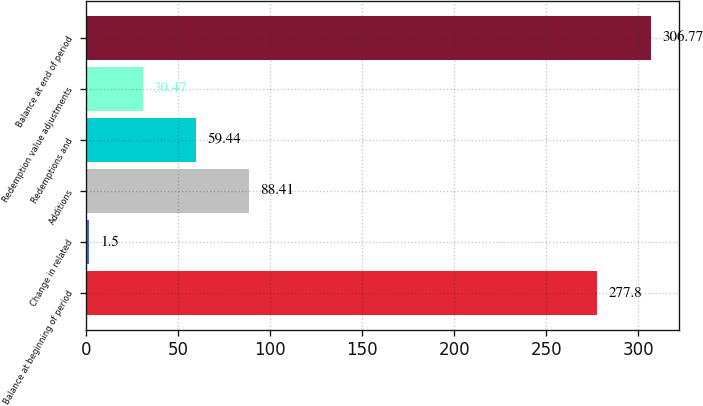Convert chart to OTSL. <chart><loc_0><loc_0><loc_500><loc_500><bar_chart><fcel>Balance at beginning of period<fcel>Change in related<fcel>Additions<fcel>Redemptions and<fcel>Redemption value adjustments<fcel>Balance at end of period<nl><fcel>277.8<fcel>1.5<fcel>88.41<fcel>59.44<fcel>30.47<fcel>306.77<nl></chart> 